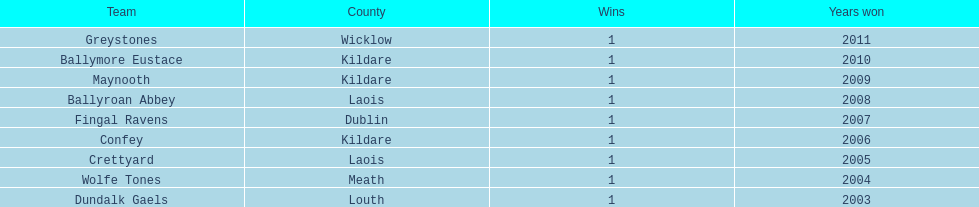Which team won previous to crettyard? Wolfe Tones. 